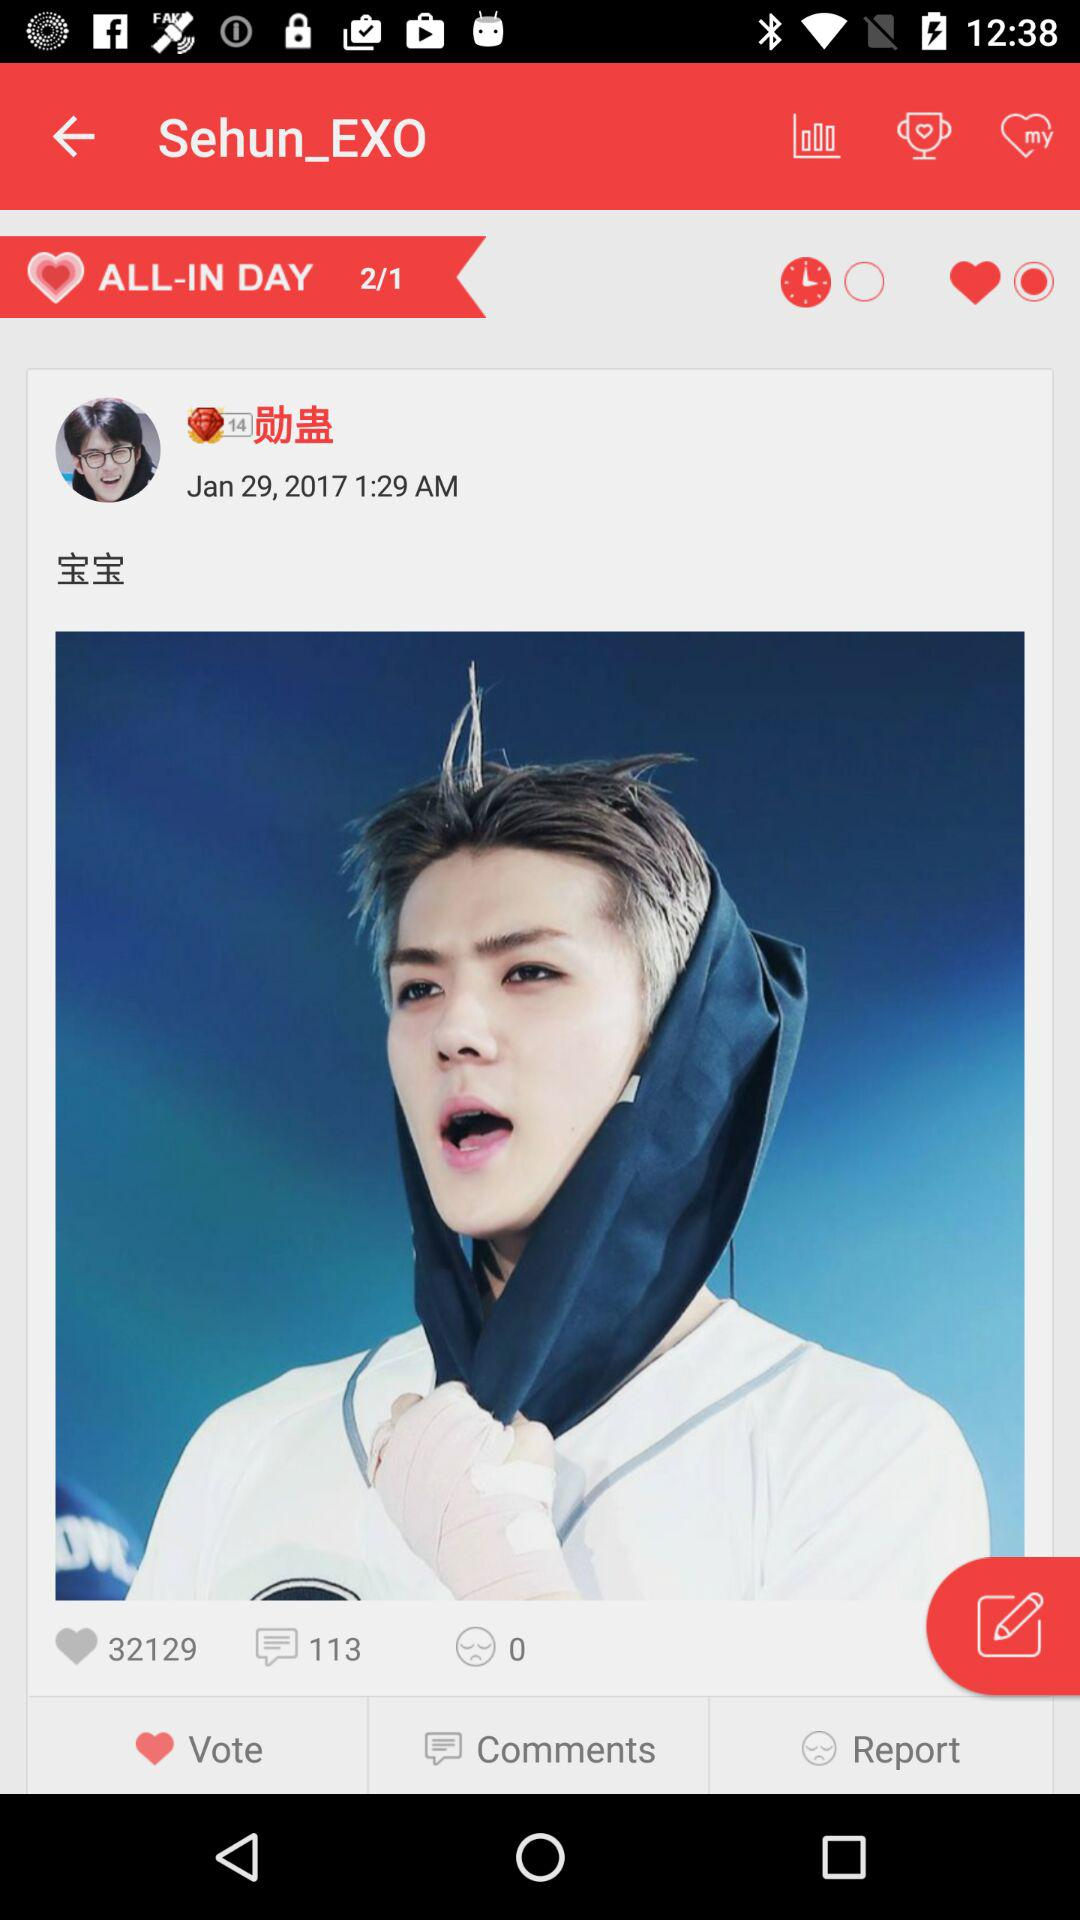What is the username? The username is "Sehun_EXO". 